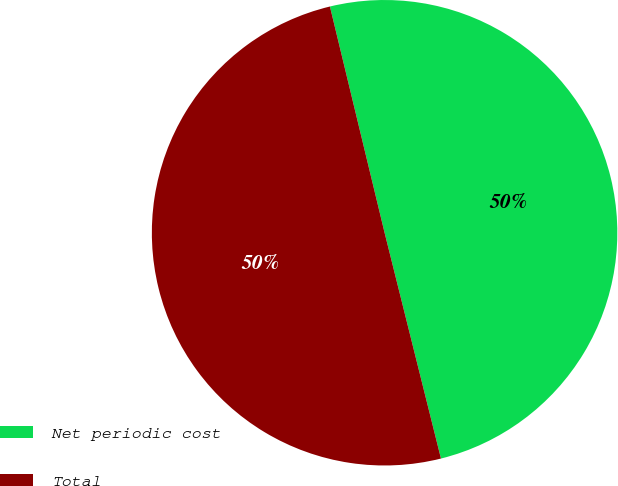Convert chart to OTSL. <chart><loc_0><loc_0><loc_500><loc_500><pie_chart><fcel>Net periodic cost<fcel>Total<nl><fcel>49.88%<fcel>50.12%<nl></chart> 